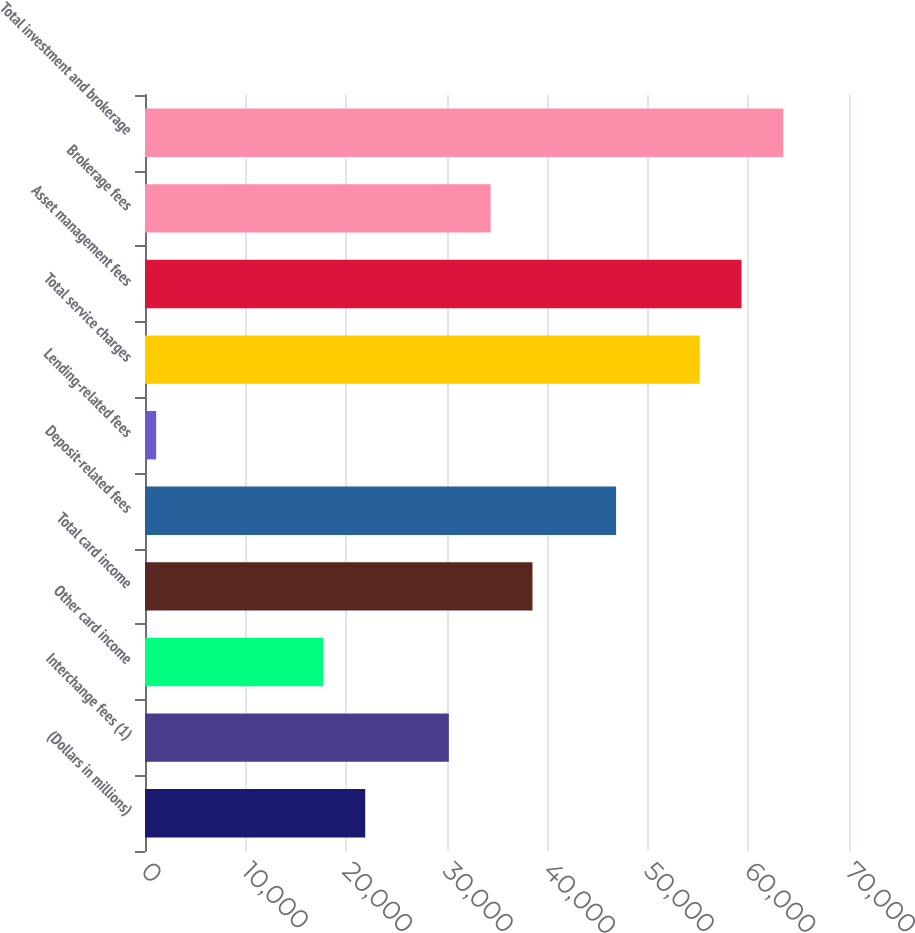<chart> <loc_0><loc_0><loc_500><loc_500><bar_chart><fcel>(Dollars in millions)<fcel>Interchange fees (1)<fcel>Other card income<fcel>Total card income<fcel>Deposit-related fees<fcel>Lending-related fees<fcel>Total service charges<fcel>Asset management fees<fcel>Brokerage fees<fcel>Total investment and brokerage<nl><fcel>21897.5<fcel>30212.5<fcel>17740<fcel>38527.5<fcel>46842.5<fcel>1110<fcel>55157.5<fcel>59315<fcel>34370<fcel>63472.5<nl></chart> 